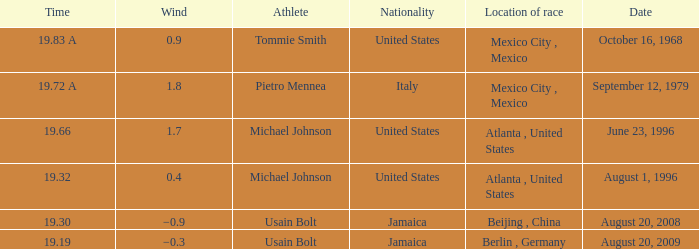What's the wind when the time was 19.32? 0.4. 